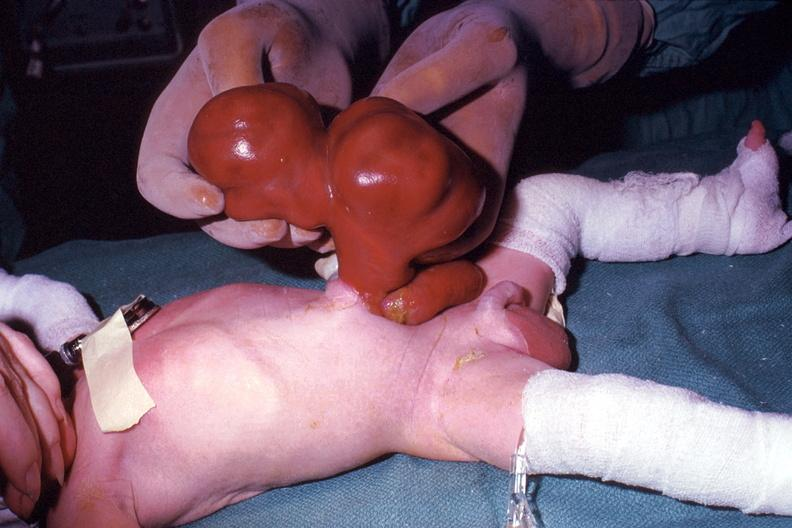s abdomen present?
Answer the question using a single word or phrase. Yes 